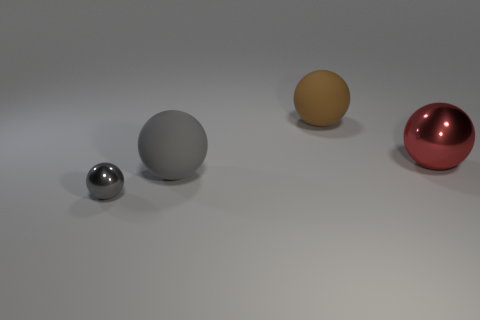Subtract all big spheres. How many spheres are left? 1 Add 4 large gray shiny things. How many objects exist? 8 Subtract all green spheres. Subtract all red cubes. How many spheres are left? 4 Add 4 big red balls. How many big red balls exist? 5 Subtract 0 blue balls. How many objects are left? 4 Subtract all big objects. Subtract all blue metal blocks. How many objects are left? 1 Add 3 big brown rubber objects. How many big brown rubber objects are left? 4 